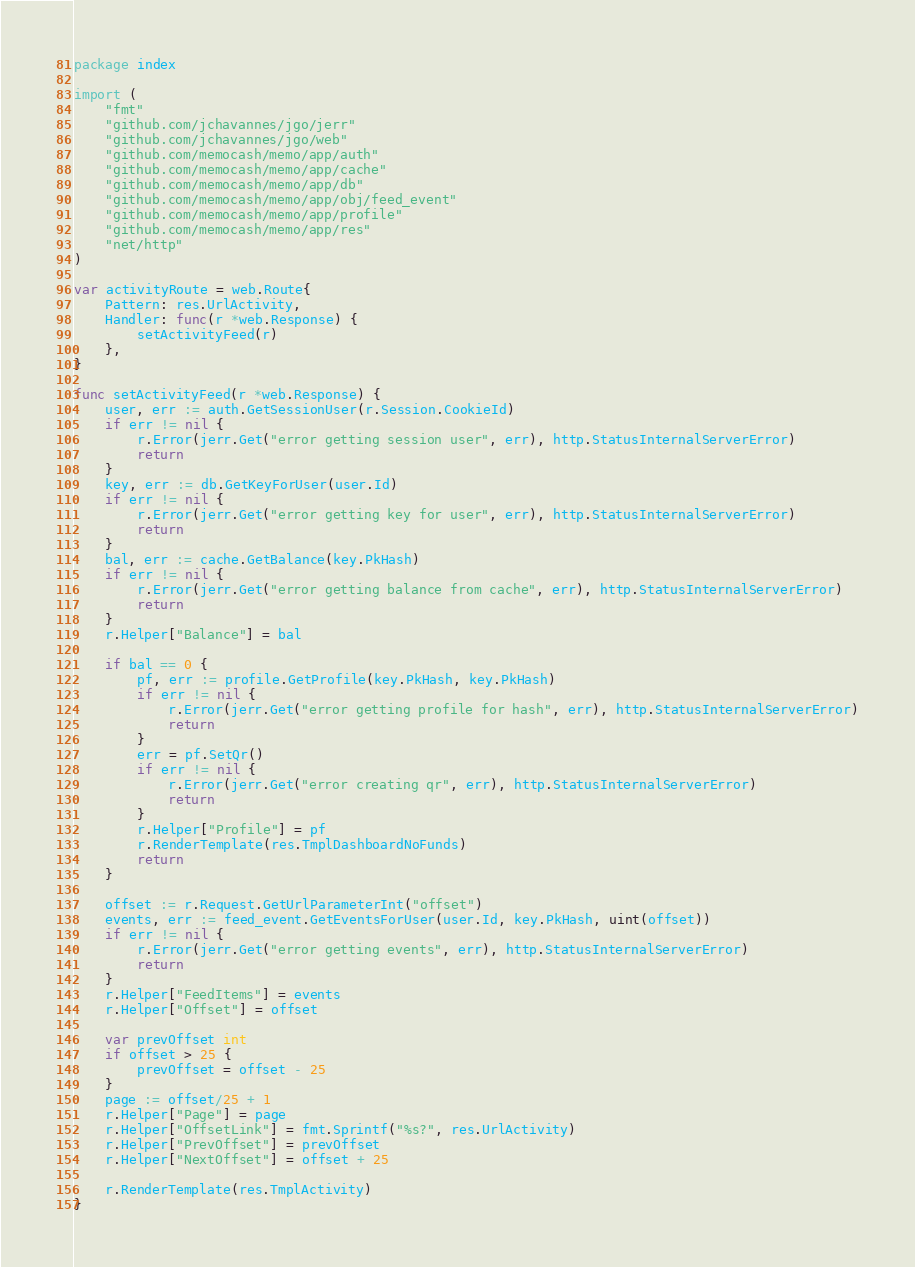Convert code to text. <code><loc_0><loc_0><loc_500><loc_500><_Go_>package index

import (
	"fmt"
	"github.com/jchavannes/jgo/jerr"
	"github.com/jchavannes/jgo/web"
	"github.com/memocash/memo/app/auth"
	"github.com/memocash/memo/app/cache"
	"github.com/memocash/memo/app/db"
	"github.com/memocash/memo/app/obj/feed_event"
	"github.com/memocash/memo/app/profile"
	"github.com/memocash/memo/app/res"
	"net/http"
)

var activityRoute = web.Route{
	Pattern: res.UrlActivity,
	Handler: func(r *web.Response) {
		setActivityFeed(r)
	},
}

func setActivityFeed(r *web.Response) {
	user, err := auth.GetSessionUser(r.Session.CookieId)
	if err != nil {
		r.Error(jerr.Get("error getting session user", err), http.StatusInternalServerError)
		return
	}
	key, err := db.GetKeyForUser(user.Id)
	if err != nil {
		r.Error(jerr.Get("error getting key for user", err), http.StatusInternalServerError)
		return
	}
	bal, err := cache.GetBalance(key.PkHash)
	if err != nil {
		r.Error(jerr.Get("error getting balance from cache", err), http.StatusInternalServerError)
		return
	}
	r.Helper["Balance"] = bal

	if bal == 0 {
		pf, err := profile.GetProfile(key.PkHash, key.PkHash)
		if err != nil {
			r.Error(jerr.Get("error getting profile for hash", err), http.StatusInternalServerError)
			return
		}
		err = pf.SetQr()
		if err != nil {
			r.Error(jerr.Get("error creating qr", err), http.StatusInternalServerError)
			return
		}
		r.Helper["Profile"] = pf
		r.RenderTemplate(res.TmplDashboardNoFunds)
		return
	}

	offset := r.Request.GetUrlParameterInt("offset")
	events, err := feed_event.GetEventsForUser(user.Id, key.PkHash, uint(offset))
	if err != nil {
		r.Error(jerr.Get("error getting events", err), http.StatusInternalServerError)
		return
	}
	r.Helper["FeedItems"] = events
	r.Helper["Offset"] = offset

	var prevOffset int
	if offset > 25 {
		prevOffset = offset - 25
	}
	page := offset/25 + 1
	r.Helper["Page"] = page
	r.Helper["OffsetLink"] = fmt.Sprintf("%s?", res.UrlActivity)
	r.Helper["PrevOffset"] = prevOffset
	r.Helper["NextOffset"] = offset + 25

	r.RenderTemplate(res.TmplActivity)
}
</code> 